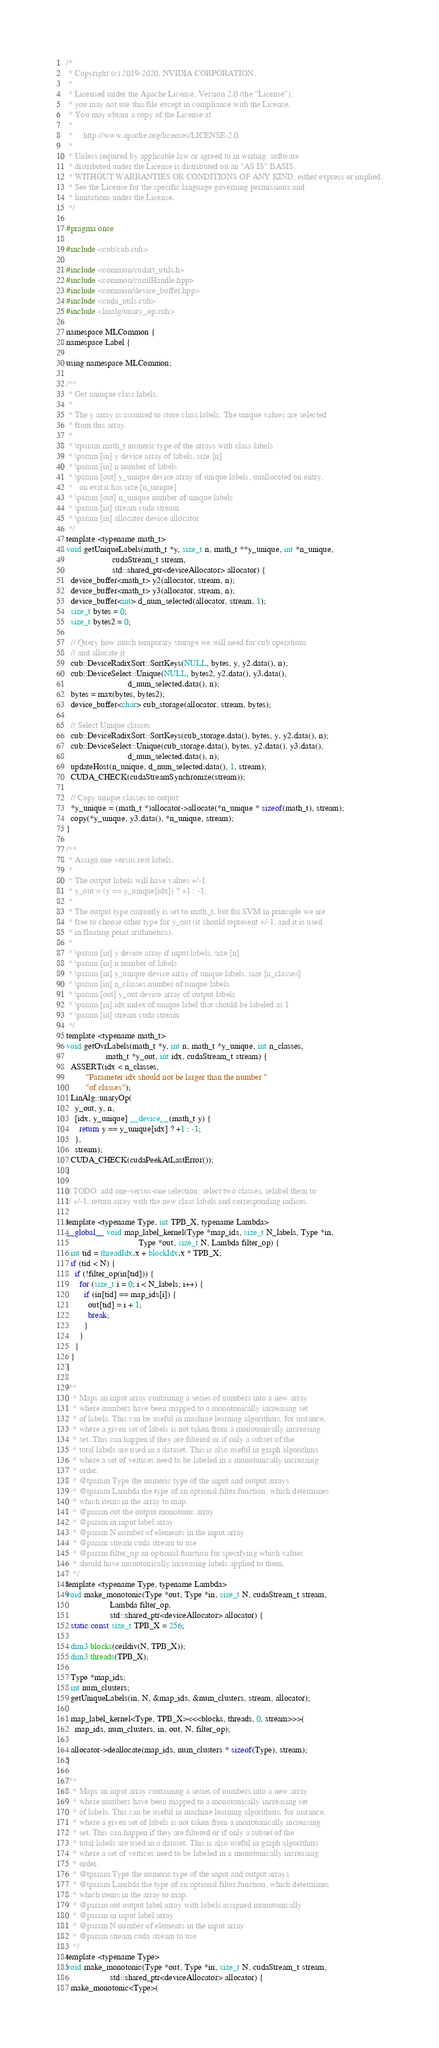Convert code to text. <code><loc_0><loc_0><loc_500><loc_500><_Cuda_>/*
 * Copyright (c) 2019-2020, NVIDIA CORPORATION.
 *
 * Licensed under the Apache License, Version 2.0 (the "License");
 * you may not use this file except in compliance with the License.
 * You may obtain a copy of the License at
 *
 *     http://www.apache.org/licenses/LICENSE-2.0
 *
 * Unless required by applicable law or agreed to in writing, software
 * distributed under the License is distributed on an "AS IS" BASIS,
 * WITHOUT WARRANTIES OR CONDITIONS OF ANY KIND, either express or implied.
 * See the License for the specific language governing permissions and
 * limitations under the License.
 */

#pragma once

#include <cub/cub.cuh>

#include <common/cudart_utils.h>
#include <common/cumlHandle.hpp>
#include <common/device_buffer.hpp>
#include <cuda_utils.cuh>
#include <linalg/unary_op.cuh>

namespace MLCommon {
namespace Label {

using namespace MLCommon;

/**
 * Get uniuque class labels.
 *
 * The y array is assumed to store class labels. The unique values are selected
 * from this array.
 *
 * \tparam math_t numeric type of the arrays with class labels
 * \param [in] y device array of labels, size [n]
 * \param [in] n number of labels
 * \param [out] y_unique device array of unique labels, unallocated on entry,
 *   on exit it has size [n_unique]
 * \param [out] n_unique number of unique labels
 * \param [in] stream cuda stream
 * \param [in] allocator device allocator
 */
template <typename math_t>
void getUniqueLabels(math_t *y, size_t n, math_t **y_unique, int *n_unique,
                     cudaStream_t stream,
                     std::shared_ptr<deviceAllocator> allocator) {
  device_buffer<math_t> y2(allocator, stream, n);
  device_buffer<math_t> y3(allocator, stream, n);
  device_buffer<int> d_num_selected(allocator, stream, 1);
  size_t bytes = 0;
  size_t bytes2 = 0;

  // Query how much temporary storage we will need for cub operations
  // and allocate it
  cub::DeviceRadixSort::SortKeys(NULL, bytes, y, y2.data(), n);
  cub::DeviceSelect::Unique(NULL, bytes2, y2.data(), y3.data(),
                            d_num_selected.data(), n);
  bytes = max(bytes, bytes2);
  device_buffer<char> cub_storage(allocator, stream, bytes);

  // Select Unique classes
  cub::DeviceRadixSort::SortKeys(cub_storage.data(), bytes, y, y2.data(), n);
  cub::DeviceSelect::Unique(cub_storage.data(), bytes, y2.data(), y3.data(),
                            d_num_selected.data(), n);
  updateHost(n_unique, d_num_selected.data(), 1, stream);
  CUDA_CHECK(cudaStreamSynchronize(stream));

  // Copy unique classes to output
  *y_unique = (math_t *)allocator->allocate(*n_unique * sizeof(math_t), stream);
  copy(*y_unique, y3.data(), *n_unique, stream);
}

/**
 * Assign one versus rest labels.
 *
 * The output labels will have values +/-1:
 * y_out = (y == y_unique[idx]) ? +1 : -1;
 *
 * The output type currently is set to math_t, but for SVM in principle we are
 * free to choose other type for y_out (it should represent +/-1, and it is used
 * in floating point arithmetics).
 *
 * \param [in] y device array if input labels, size [n]
 * \param [in] n number of labels
 * \param [in] y_unique device array of unique labels, size [n_classes]
 * \param [in] n_classes number of unique labels
 * \param [out] y_out device array of output labels
 * \param [in] idx index of unique label that should be labeled as 1
 * \param [in] stream cuda stream
 */
template <typename math_t>
void getOvrLabels(math_t *y, int n, math_t *y_unique, int n_classes,
                  math_t *y_out, int idx, cudaStream_t stream) {
  ASSERT(idx < n_classes,
         "Parameter idx should not be larger than the number "
         "of classes");
  LinAlg::unaryOp(
    y_out, y, n,
    [idx, y_unique] __device__(math_t y) {
      return y == y_unique[idx] ? +1 : -1;
    },
    stream);
  CUDA_CHECK(cudaPeekAtLastError());
}

// TODO: add one-versus-one selection: select two classes, relabel them to
// +/-1, return array with the new class labels and corresponding indices.

template <typename Type, int TPB_X, typename Lambda>
__global__ void map_label_kernel(Type *map_ids, size_t N_labels, Type *in,
                                 Type *out, size_t N, Lambda filter_op) {
  int tid = threadIdx.x + blockIdx.x * TPB_X;
  if (tid < N) {
    if (!filter_op(in[tid])) {
      for (size_t i = 0; i < N_labels; i++) {
        if (in[tid] == map_ids[i]) {
          out[tid] = i + 1;
          break;
        }
      }
    }
  }
}

/**
   * Maps an input array containing a series of numbers into a new array
   * where numbers have been mapped to a monotonically increasing set
   * of labels. This can be useful in machine learning algorithms, for instance,
   * where a given set of labels is not taken from a monotonically increasing
   * set. This can happen if they are filtered or if only a subset of the
   * total labels are used in a dataset. This is also useful in graph algorithms
   * where a set of vertices need to be labeled in a monotonically increasing
   * order.
   * @tparam Type the numeric type of the input and output arrays
   * @tparam Lambda the type of an optional filter function, which determines
   * which items in the array to map.
   * @param out the output monotonic array
   * @param in input label array
   * @param N number of elements in the input array
   * @param stream cuda stream to use
   * @param filter_op an optional function for specifying which values
   * should have monotonically increasing labels applied to them.
   */
template <typename Type, typename Lambda>
void make_monotonic(Type *out, Type *in, size_t N, cudaStream_t stream,
                    Lambda filter_op,
                    std::shared_ptr<deviceAllocator> allocator) {
  static const size_t TPB_X = 256;

  dim3 blocks(ceildiv(N, TPB_X));
  dim3 threads(TPB_X);

  Type *map_ids;
  int num_clusters;
  getUniqueLabels(in, N, &map_ids, &num_clusters, stream, allocator);

  map_label_kernel<Type, TPB_X><<<blocks, threads, 0, stream>>>(
    map_ids, num_clusters, in, out, N, filter_op);

  allocator->deallocate(map_ids, num_clusters * sizeof(Type), stream);
}

/**
   * Maps an input array containing a series of numbers into a new array
   * where numbers have been mapped to a monotonically increasing set
   * of labels. This can be useful in machine learning algorithms, for instance,
   * where a given set of labels is not taken from a monotonically increasing
   * set. This can happen if they are filtered or if only a subset of the
   * total labels are used in a dataset. This is also useful in graph algorithms
   * where a set of vertices need to be labeled in a monotonically increasing
   * order.
   * @tparam Type the numeric type of the input and output arrays
   * @tparam Lambda the type of an optional filter function, which determines
   * which items in the array to map.
   * @param out output label array with labels assigned monotonically
   * @param in input label array
   * @param N number of elements in the input array
   * @param stream cuda stream to use
   */
template <typename Type>
void make_monotonic(Type *out, Type *in, size_t N, cudaStream_t stream,
                    std::shared_ptr<deviceAllocator> allocator) {
  make_monotonic<Type>(</code> 